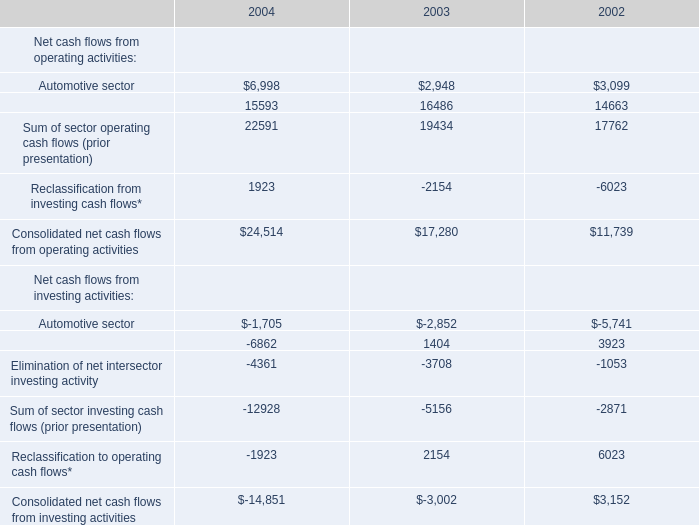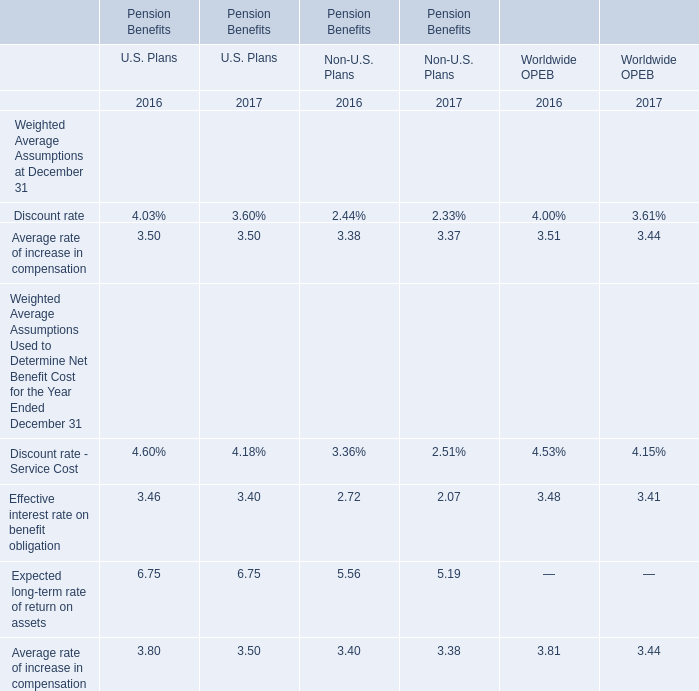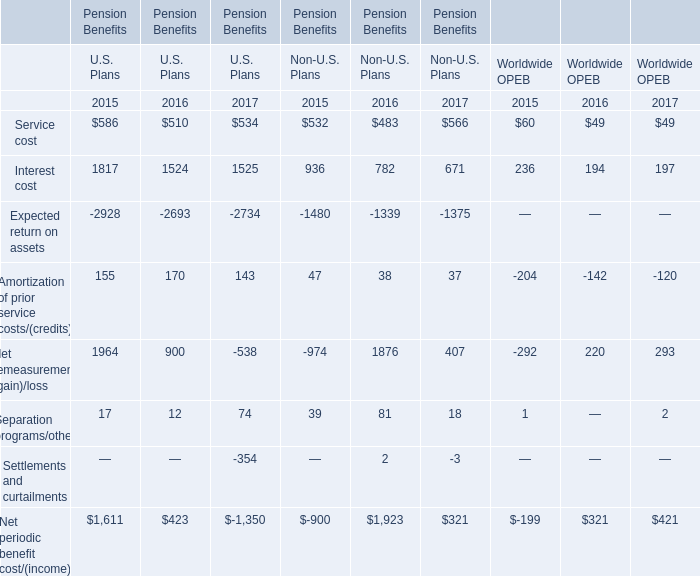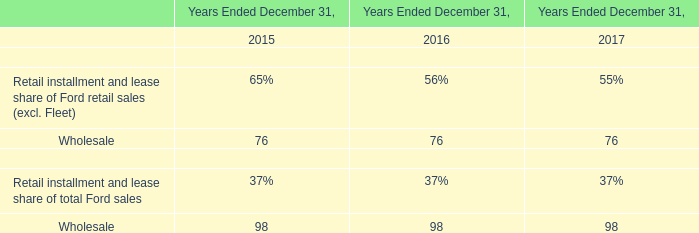Which year of Non-U.S. Plans is Separation programs/other the highest? 
Answer: 2016. 